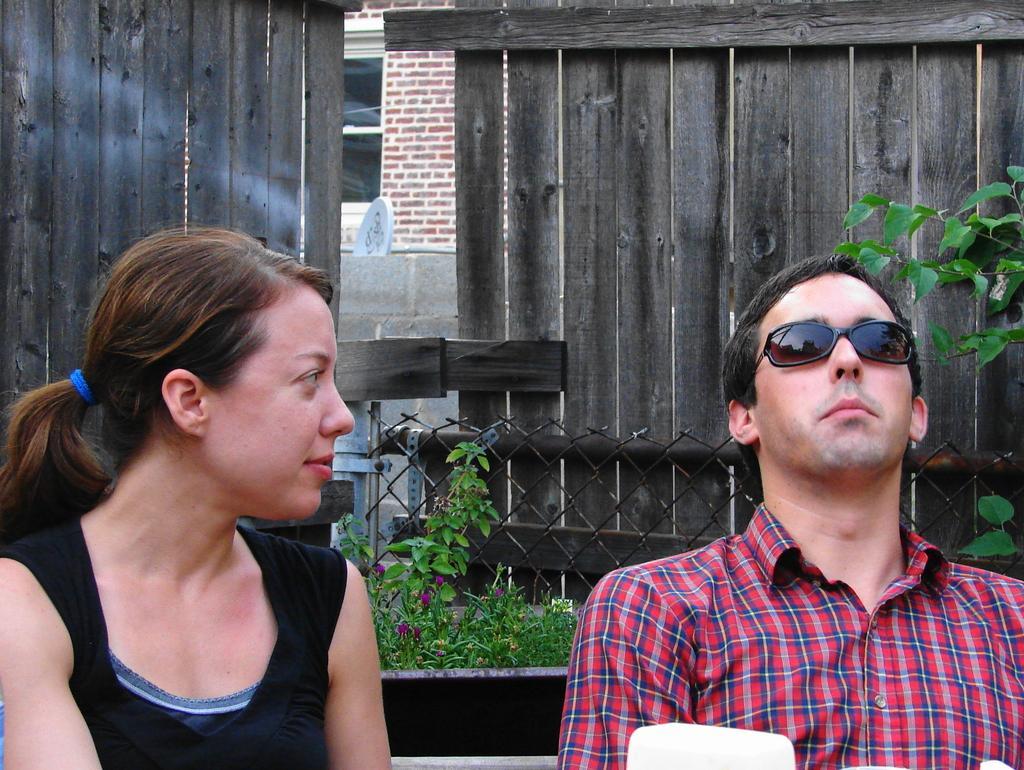In one or two sentences, can you explain what this image depicts? In this image we can see a man and a woman sitting. On the backside we can see some plants with flowers, a metal fence, wall, a dish and a board with some text on it. 